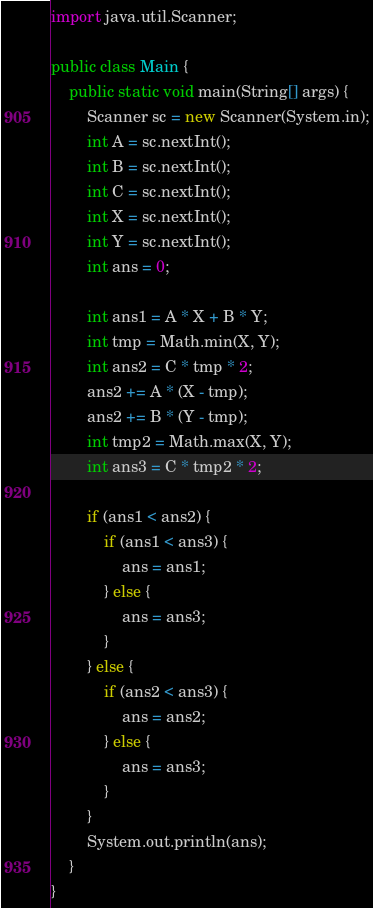Convert code to text. <code><loc_0><loc_0><loc_500><loc_500><_Java_>import java.util.Scanner;

public class Main {
	public static void main(String[] args) {
		Scanner sc = new Scanner(System.in);
		int A = sc.nextInt();
		int B = sc.nextInt();
		int C = sc.nextInt();
		int X = sc.nextInt();
		int Y = sc.nextInt();
		int ans = 0;

		int ans1 = A * X + B * Y;
		int tmp = Math.min(X, Y);
		int ans2 = C * tmp * 2;
		ans2 += A * (X - tmp);
		ans2 += B * (Y - tmp);
		int tmp2 = Math.max(X, Y);
		int ans3 = C * tmp2 * 2;

		if (ans1 < ans2) {
			if (ans1 < ans3) {
				ans = ans1;
			} else {
				ans = ans3;
			}
		} else {
			if (ans2 < ans3) {
				ans = ans2;
			} else {
				ans = ans3;
			}
		}
		System.out.println(ans);
	}
}
</code> 